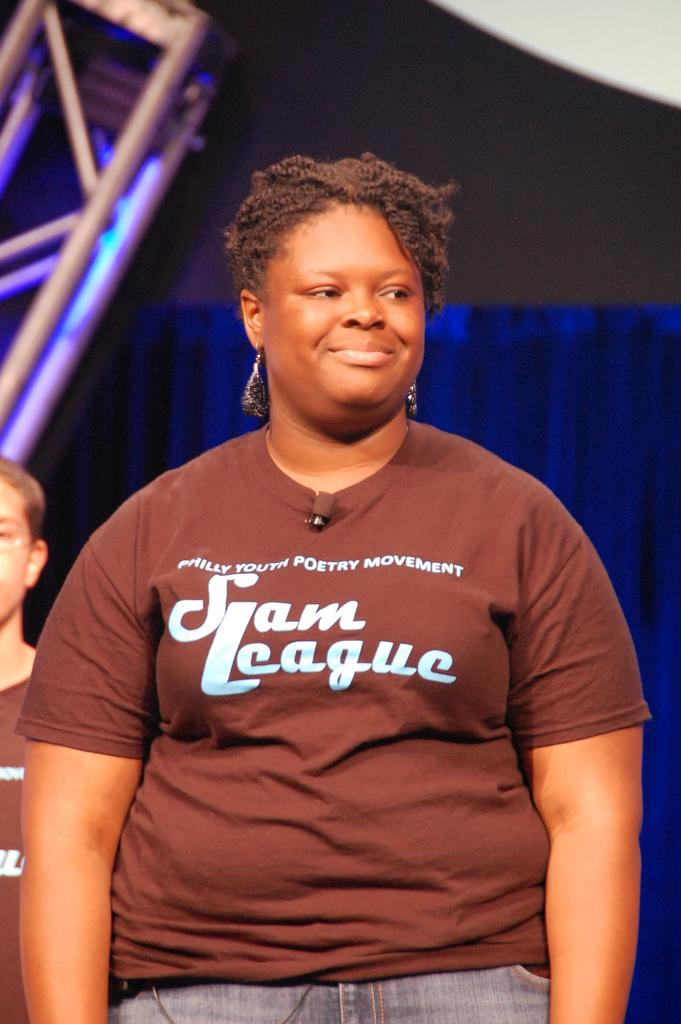Provide a one-sentence caption for the provided image. A member of a Philadelphia poetry league wears her club's t-shirt. 